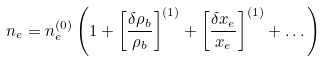<formula> <loc_0><loc_0><loc_500><loc_500>n _ { e } = n _ { e } ^ { ( 0 ) } \left ( 1 + \left [ \frac { \delta \rho _ { b } } { \rho _ { b } } \right ] ^ { ( 1 ) } + \left [ \frac { \delta x _ { e } } { x _ { e } } \right ] ^ { ( 1 ) } + \dots \right )</formula> 